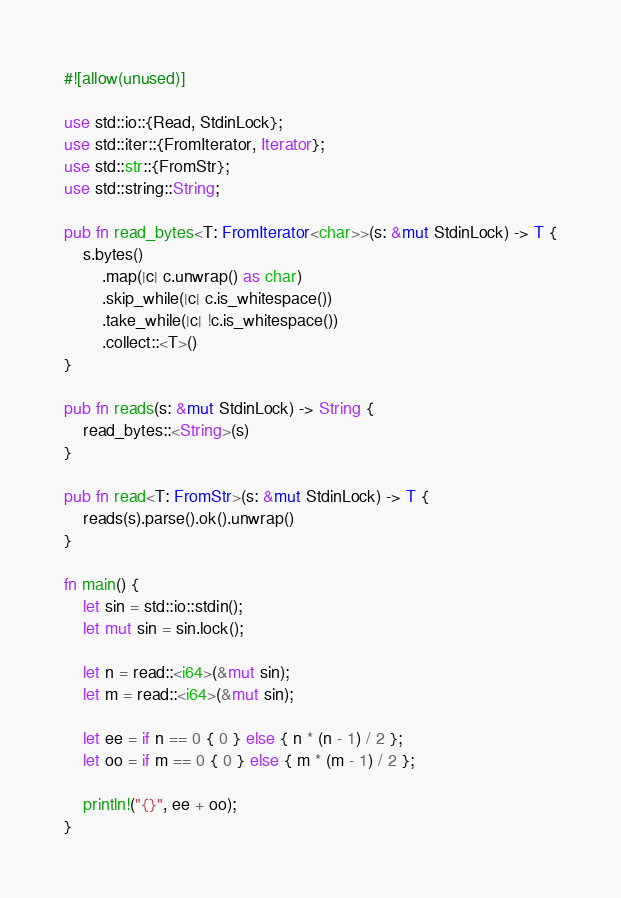<code> <loc_0><loc_0><loc_500><loc_500><_Rust_>#![allow(unused)]

use std::io::{Read, StdinLock};
use std::iter::{FromIterator, Iterator};
use std::str::{FromStr};
use std::string::String;

pub fn read_bytes<T: FromIterator<char>>(s: &mut StdinLock) -> T {
    s.bytes()
        .map(|c| c.unwrap() as char)
        .skip_while(|c| c.is_whitespace())
        .take_while(|c| !c.is_whitespace())
        .collect::<T>()
}

pub fn reads(s: &mut StdinLock) -> String {
    read_bytes::<String>(s)
}

pub fn read<T: FromStr>(s: &mut StdinLock) -> T {
    reads(s).parse().ok().unwrap()
}

fn main() {
    let sin = std::io::stdin();
    let mut sin = sin.lock();

    let n = read::<i64>(&mut sin);
    let m = read::<i64>(&mut sin);

    let ee = if n == 0 { 0 } else { n * (n - 1) / 2 };
    let oo = if m == 0 { 0 } else { m * (m - 1) / 2 };

    println!("{}", ee + oo);
}</code> 